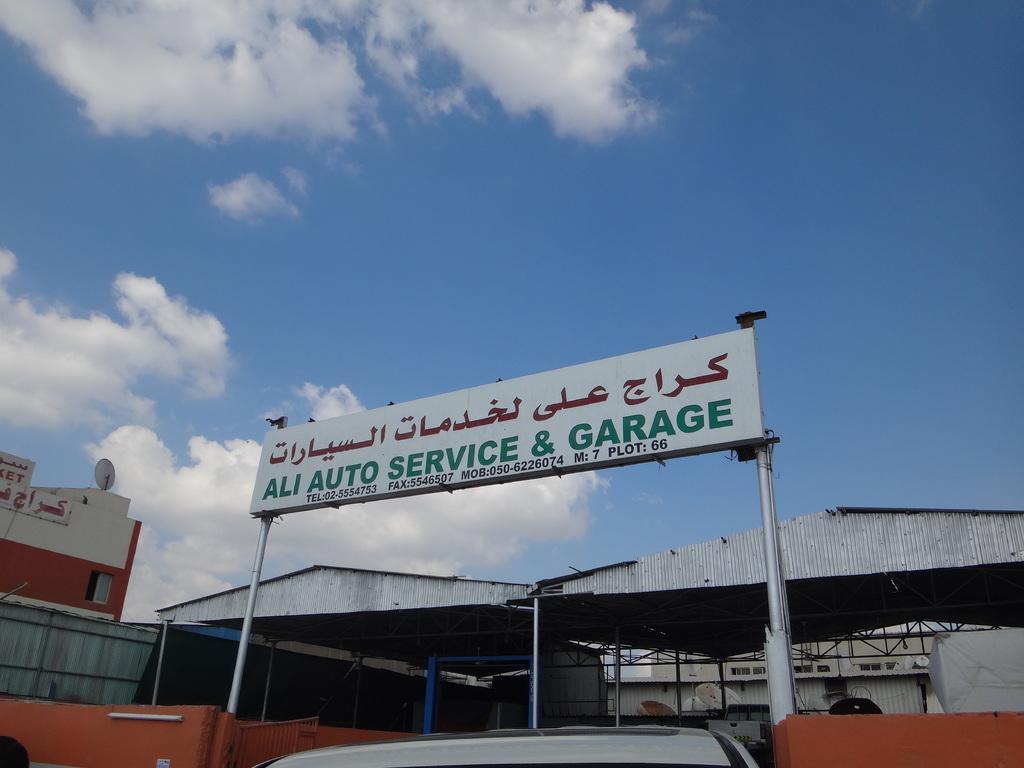Can you describe this image briefly? In the picture we can see a mechanic shed with a board on it, we can see a name Ali service and a garage and behind it, we can see two sides and beside it we can see house building and behind we can see a sky with clouds. 